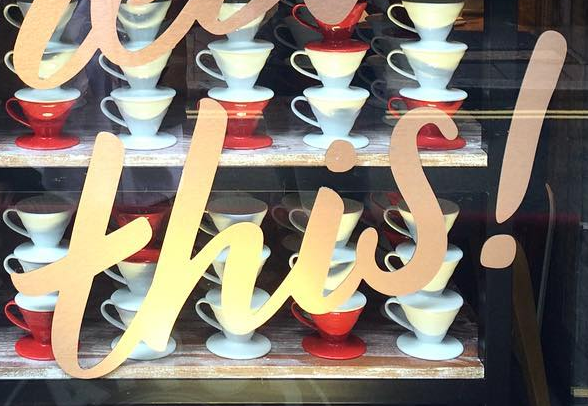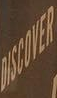Transcribe the words shown in these images in order, separated by a semicolon. this!; DISCOVER 